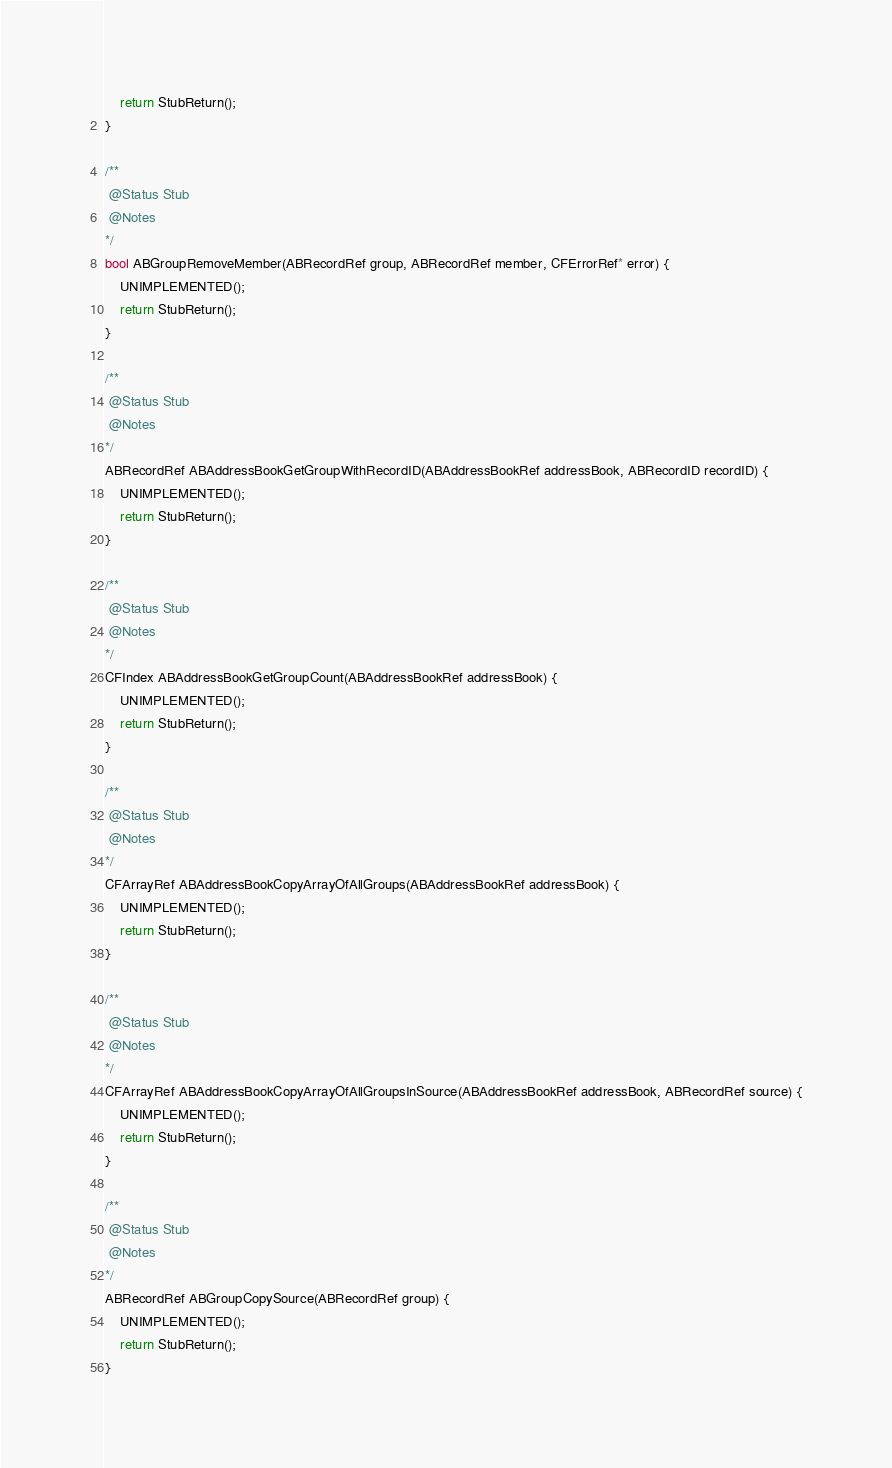Convert code to text. <code><loc_0><loc_0><loc_500><loc_500><_ObjectiveC_>    return StubReturn();
}

/**
 @Status Stub
 @Notes
*/
bool ABGroupRemoveMember(ABRecordRef group, ABRecordRef member, CFErrorRef* error) {
    UNIMPLEMENTED();
    return StubReturn();
}

/**
 @Status Stub
 @Notes
*/
ABRecordRef ABAddressBookGetGroupWithRecordID(ABAddressBookRef addressBook, ABRecordID recordID) {
    UNIMPLEMENTED();
    return StubReturn();
}

/**
 @Status Stub
 @Notes
*/
CFIndex ABAddressBookGetGroupCount(ABAddressBookRef addressBook) {
    UNIMPLEMENTED();
    return StubReturn();
}

/**
 @Status Stub
 @Notes
*/
CFArrayRef ABAddressBookCopyArrayOfAllGroups(ABAddressBookRef addressBook) {
    UNIMPLEMENTED();
    return StubReturn();
}

/**
 @Status Stub
 @Notes
*/
CFArrayRef ABAddressBookCopyArrayOfAllGroupsInSource(ABAddressBookRef addressBook, ABRecordRef source) {
    UNIMPLEMENTED();
    return StubReturn();
}

/**
 @Status Stub
 @Notes
*/
ABRecordRef ABGroupCopySource(ABRecordRef group) {
    UNIMPLEMENTED();
    return StubReturn();
}
</code> 